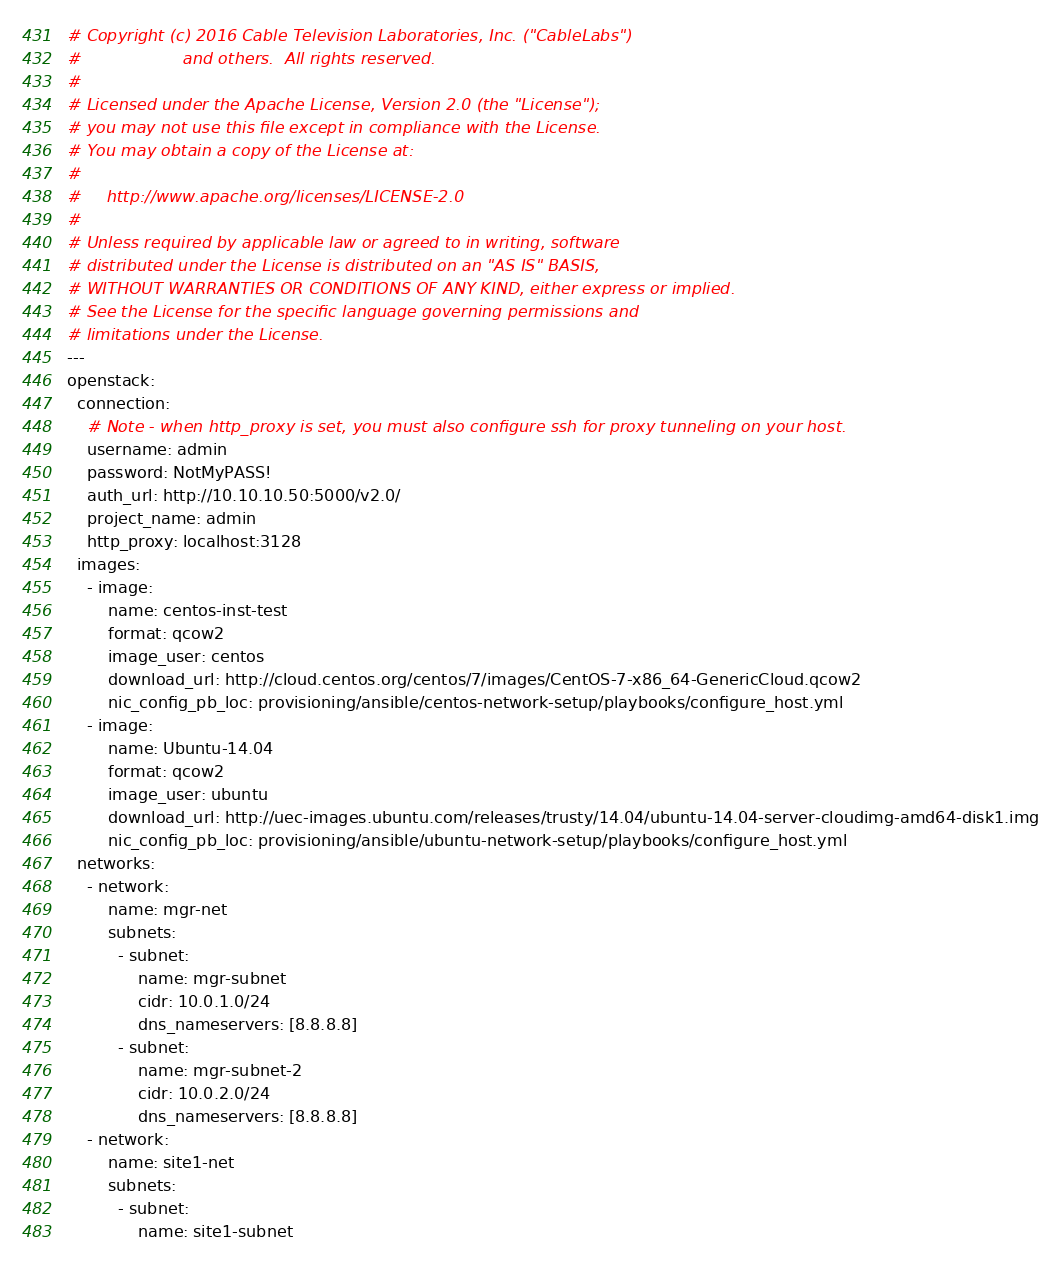Convert code to text. <code><loc_0><loc_0><loc_500><loc_500><_YAML_># Copyright (c) 2016 Cable Television Laboratories, Inc. ("CableLabs")
#                    and others.  All rights reserved.
#
# Licensed under the Apache License, Version 2.0 (the "License");
# you may not use this file except in compliance with the License.
# You may obtain a copy of the License at:
#
#     http://www.apache.org/licenses/LICENSE-2.0
#
# Unless required by applicable law or agreed to in writing, software
# distributed under the License is distributed on an "AS IS" BASIS,
# WITHOUT WARRANTIES OR CONDITIONS OF ANY KIND, either express or implied.
# See the License for the specific language governing permissions and
# limitations under the License.
---
openstack:
  connection:
    # Note - when http_proxy is set, you must also configure ssh for proxy tunneling on your host.
    username: admin
    password: NotMyPASS!
    auth_url: http://10.10.10.50:5000/v2.0/
    project_name: admin
    http_proxy: localhost:3128
  images:
    - image:
        name: centos-inst-test
        format: qcow2
        image_user: centos
        download_url: http://cloud.centos.org/centos/7/images/CentOS-7-x86_64-GenericCloud.qcow2
        nic_config_pb_loc: provisioning/ansible/centos-network-setup/playbooks/configure_host.yml
    - image:
        name: Ubuntu-14.04
        format: qcow2
        image_user: ubuntu
        download_url: http://uec-images.ubuntu.com/releases/trusty/14.04/ubuntu-14.04-server-cloudimg-amd64-disk1.img
        nic_config_pb_loc: provisioning/ansible/ubuntu-network-setup/playbooks/configure_host.yml
  networks:
    - network:
        name: mgr-net
        subnets:
          - subnet:
              name: mgr-subnet
              cidr: 10.0.1.0/24
              dns_nameservers: [8.8.8.8]
          - subnet:
              name: mgr-subnet-2
              cidr: 10.0.2.0/24
              dns_nameservers: [8.8.8.8]
    - network:
        name: site1-net
        subnets:
          - subnet:
              name: site1-subnet</code> 